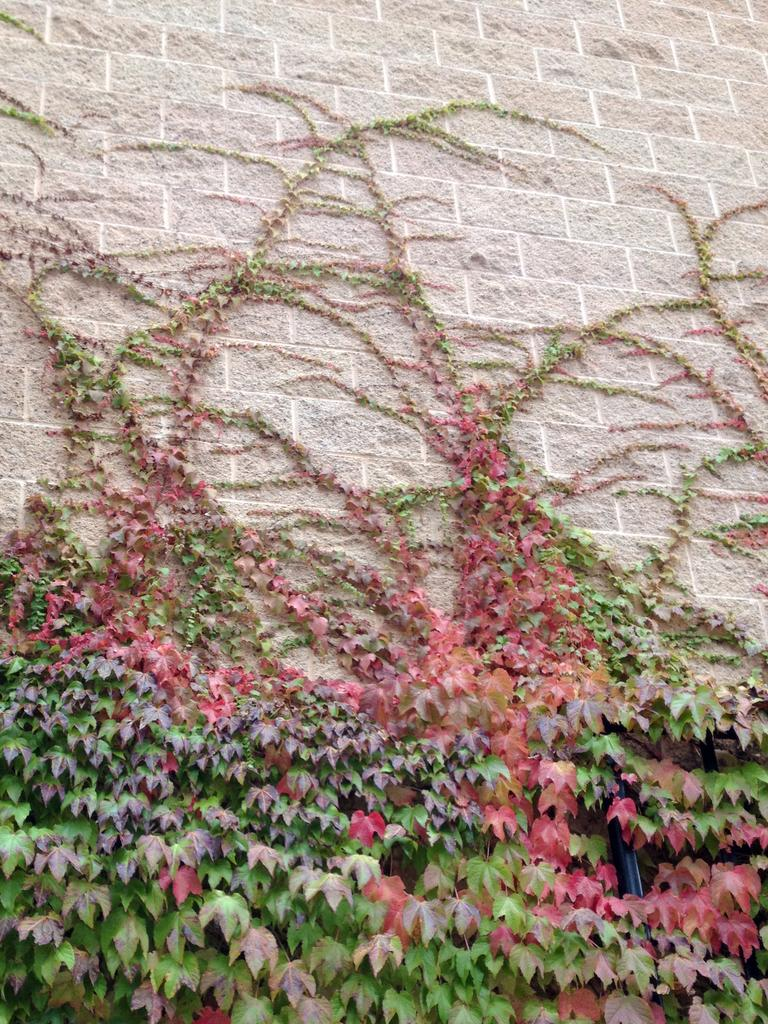What type of vegetation is present in the image? There are creepers in the image. What structure can be seen in the image? There is a pole in the image. What is the background of the image? There is a building wall in the image. Can you determine the time of day the image was taken? The image was likely taken during the day, as there is sufficient light to see the details clearly. Where is the tray located in the image? There is no tray present in the image. Can you see any toes in the image? There are no toes visible in the image. 